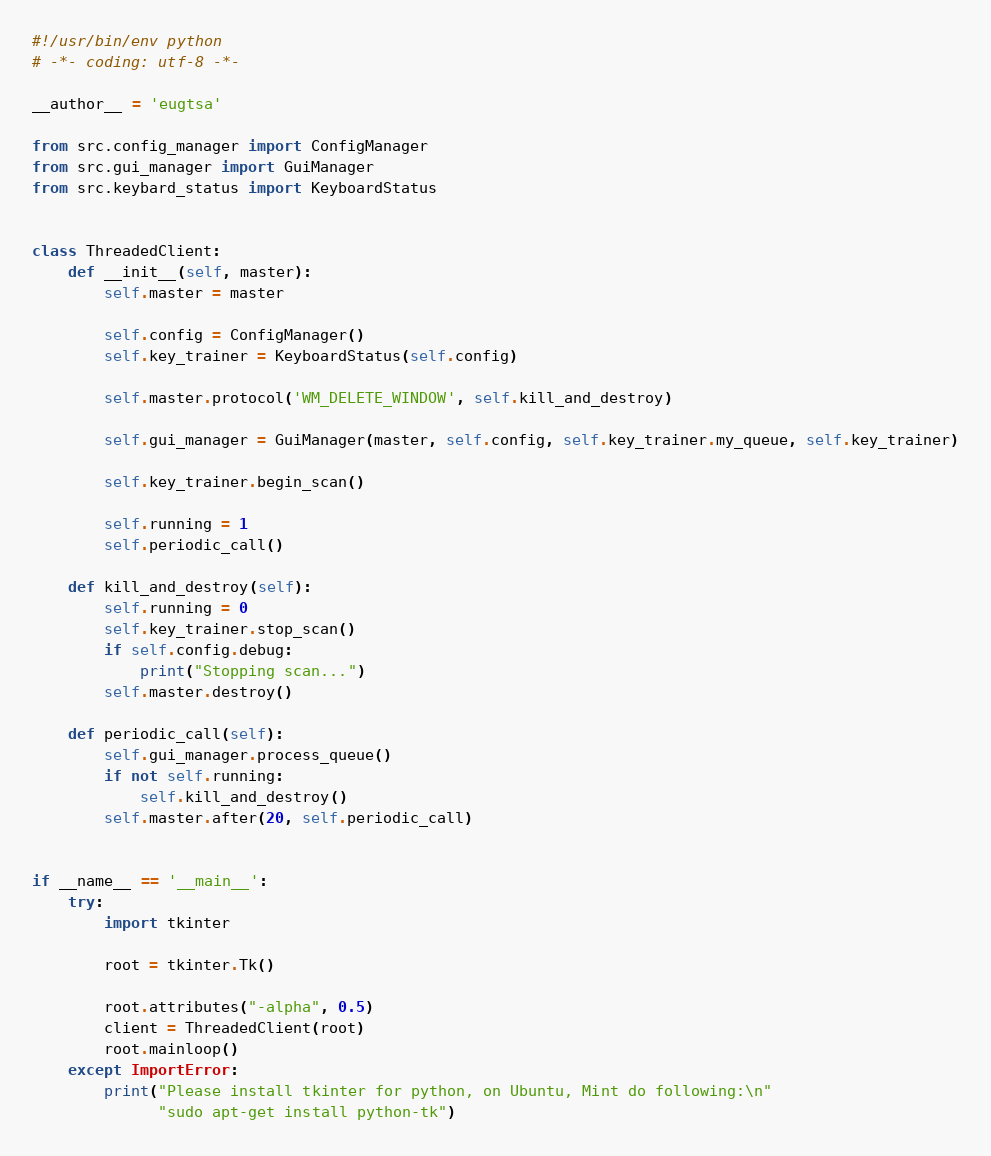Convert code to text. <code><loc_0><loc_0><loc_500><loc_500><_Python_>#!/usr/bin/env python
# -*- coding: utf-8 -*-

__author__ = 'eugtsa'

from src.config_manager import ConfigManager
from src.gui_manager import GuiManager
from src.keybard_status import KeyboardStatus


class ThreadedClient:
    def __init__(self, master):
        self.master = master

        self.config = ConfigManager()
        self.key_trainer = KeyboardStatus(self.config)

        self.master.protocol('WM_DELETE_WINDOW', self.kill_and_destroy)

        self.gui_manager = GuiManager(master, self.config, self.key_trainer.my_queue, self.key_trainer)

        self.key_trainer.begin_scan()

        self.running = 1
        self.periodic_call()

    def kill_and_destroy(self):
        self.running = 0
        self.key_trainer.stop_scan()
        if self.config.debug:
            print("Stopping scan...")
        self.master.destroy()

    def periodic_call(self):
        self.gui_manager.process_queue()
        if not self.running:
            self.kill_and_destroy()
        self.master.after(20, self.periodic_call)


if __name__ == '__main__':
    try:
        import tkinter

        root = tkinter.Tk()

        root.attributes("-alpha", 0.5)
        client = ThreadedClient(root)
        root.mainloop()
    except ImportError:
        print("Please install tkinter for python, on Ubuntu, Mint do following:\n"
              "sudo apt-get install python-tk")
</code> 